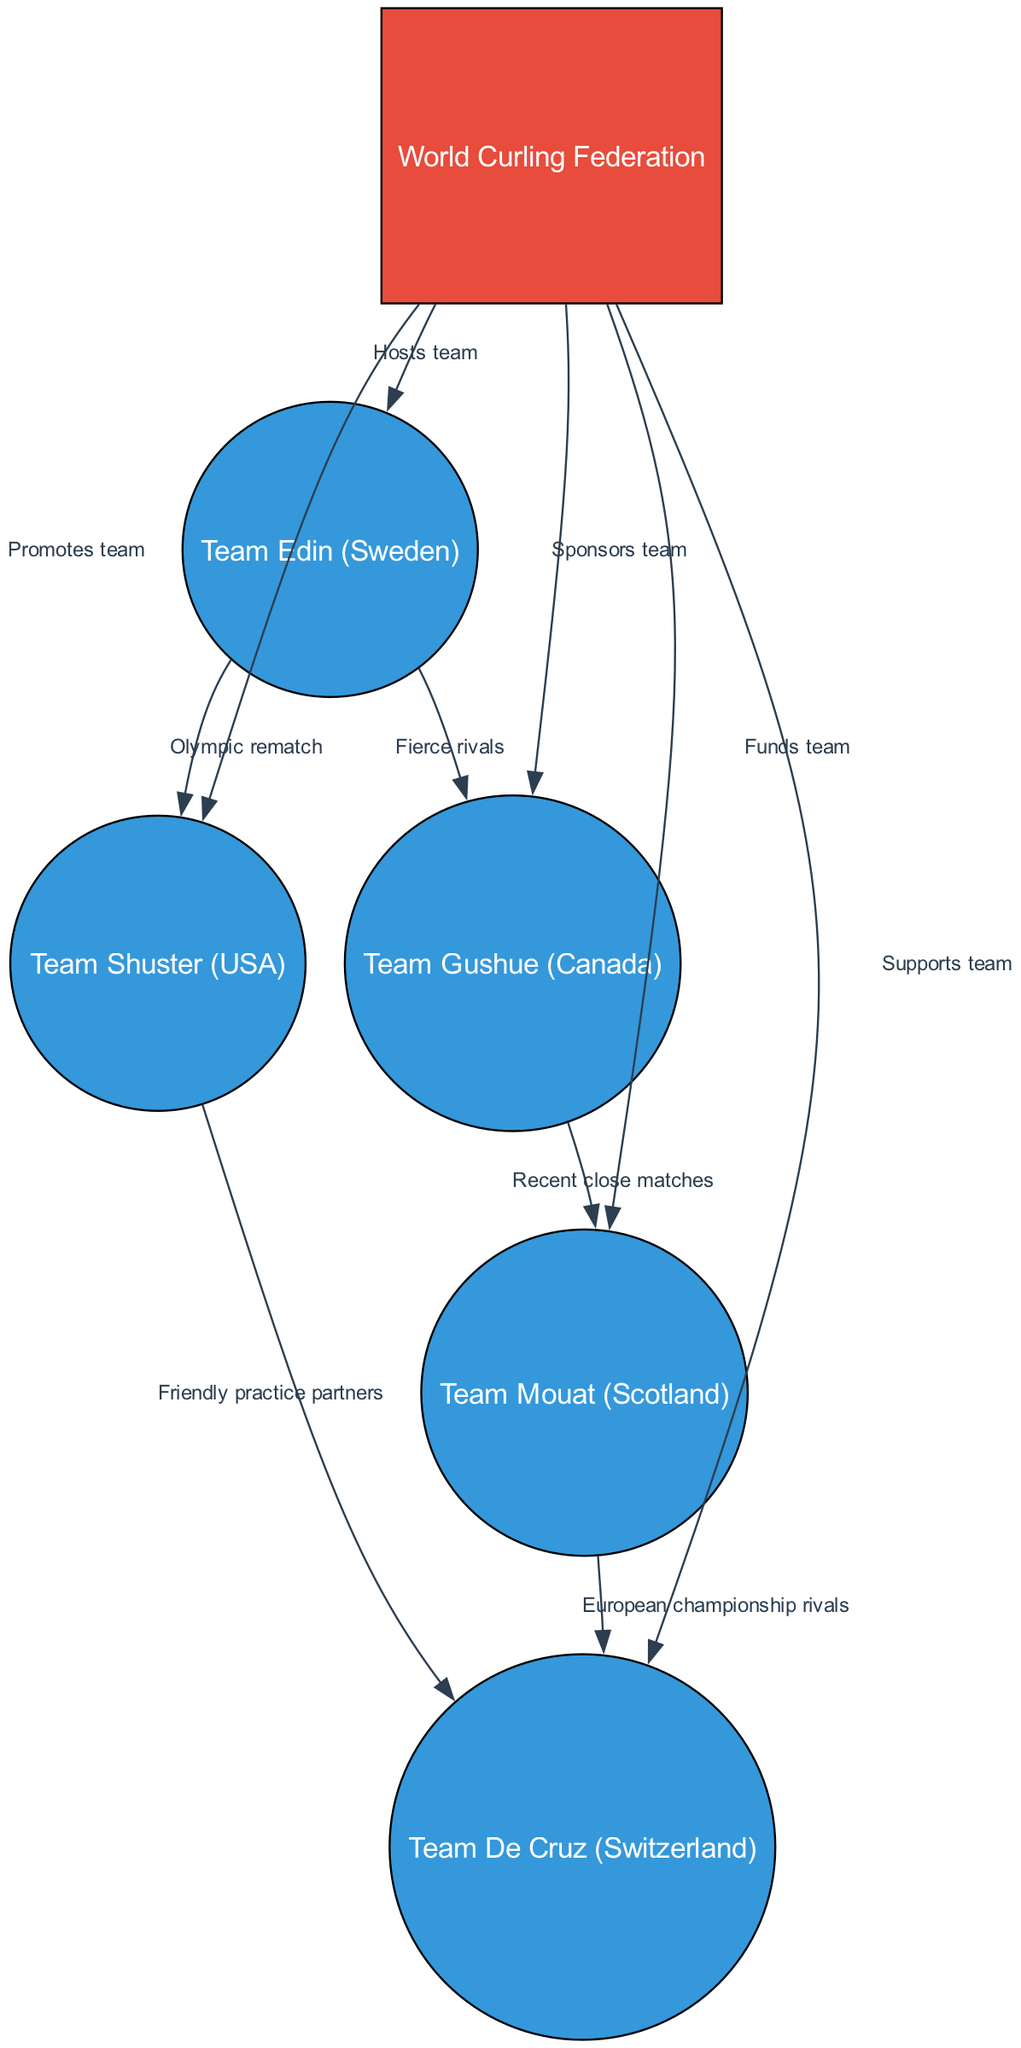What is the total number of teams depicted in the diagram? The diagram contains a list of nodes, and I can count the nodes labeled as teams. The nodes for Team Edin, Team Gushue, Team Shuster, Team Mouat, and Team De Cruz total 5 teams.
Answer: 5 Which team is shown as having fierce rivals? The edge labeled "Fierce rivals" connects Team Edin and Team Gushue. Therefore, Team Edin is directly indicated as having fierce rivals in the diagram.
Answer: Team Edin How many relationships are depicted between teams? I can count the edges connecting the team nodes to find the relationships. The edges between teams include "Fierce rivals," "Olympic rematch," "Recent close matches," "Friendly practice partners," and "European championship rivals," resulting in a total of 5 relationships.
Answer: 5 Which organization is shown to promote Team Shuster? There is an edge connecting the World Curling Federation to Team Shuster with the label "Promotes team," indicating that the organization is responsible for promoting Team Shuster.
Answer: World Curling Federation What is the relationship between Team Gushue and Team Mouat? The edge between Team Gushue and Team Mouat is labeled "Recent close matches," indicating that they have a relationship characterized by closely contested games.
Answer: Recent close matches Which team is supported by the World Curling Federation? I can refer to the edges connecting the World Curling Federation to each team. It is indicated that the World Curling Federation supports Team De Cruz, as shown by the labeled edge "Supports team."
Answer: Team De Cruz Which two teams have a friendly practice partnership? I can look for the edge labeled "Friendly practice partners," which connects Team Shuster and Team De Cruz, indicating their relationship as practice partners.
Answer: Team Shuster and Team De Cruz What color represents the teams in the diagram? The nodes for the teams are filled with blue color as per the custom color palette defined for the teams in the diagram.
Answer: Blue How many edges connect the World Curling Federation to the teams? I can count the edges that originate from the World Curling Federation node, which connects to Team Edin, Team Gushue, Team Shuster, Team Mouat, and Team De Cruz, resulting in a total of 5 edges.
Answer: 5 